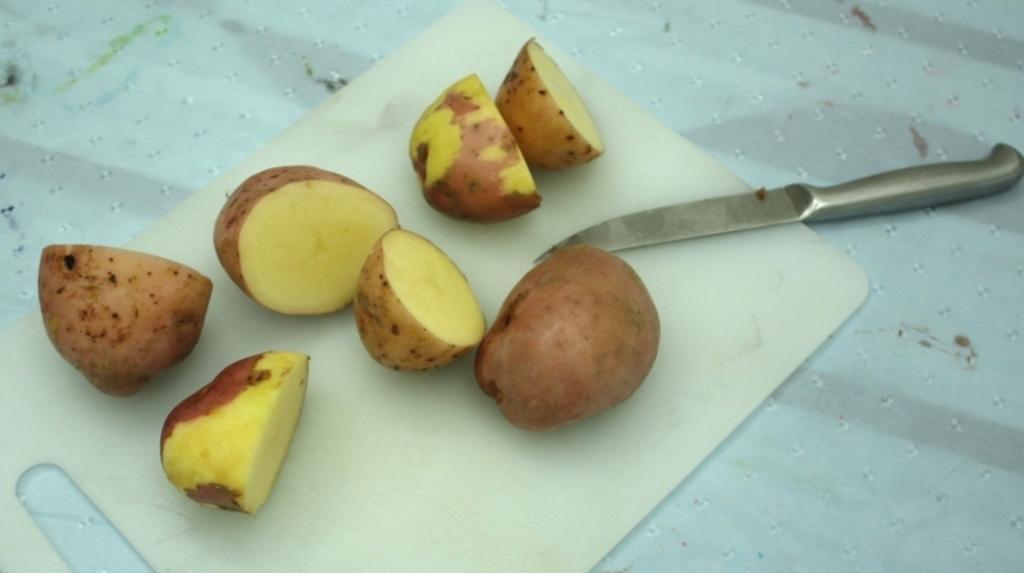Can you describe this image briefly? In this image I see the white board on which there are pieces of potatoes and I see a silver color knife over here. 